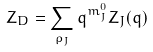Convert formula to latex. <formula><loc_0><loc_0><loc_500><loc_500>Z _ { D } = \sum _ { \rho _ { J } } q ^ { m ^ { 0 } _ { J } } Z _ { J } ( q )</formula> 